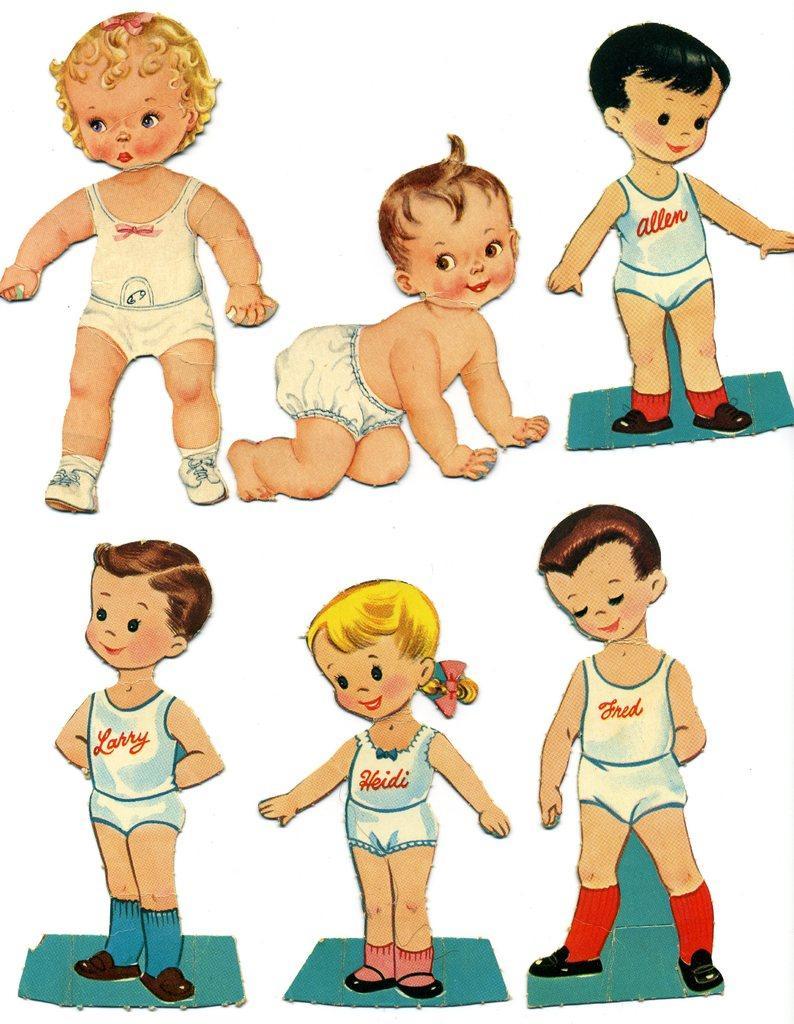In one or two sentences, can you explain what this image depicts? In this image I can see six kids may be on the floor. This image looks like an edited photo. 